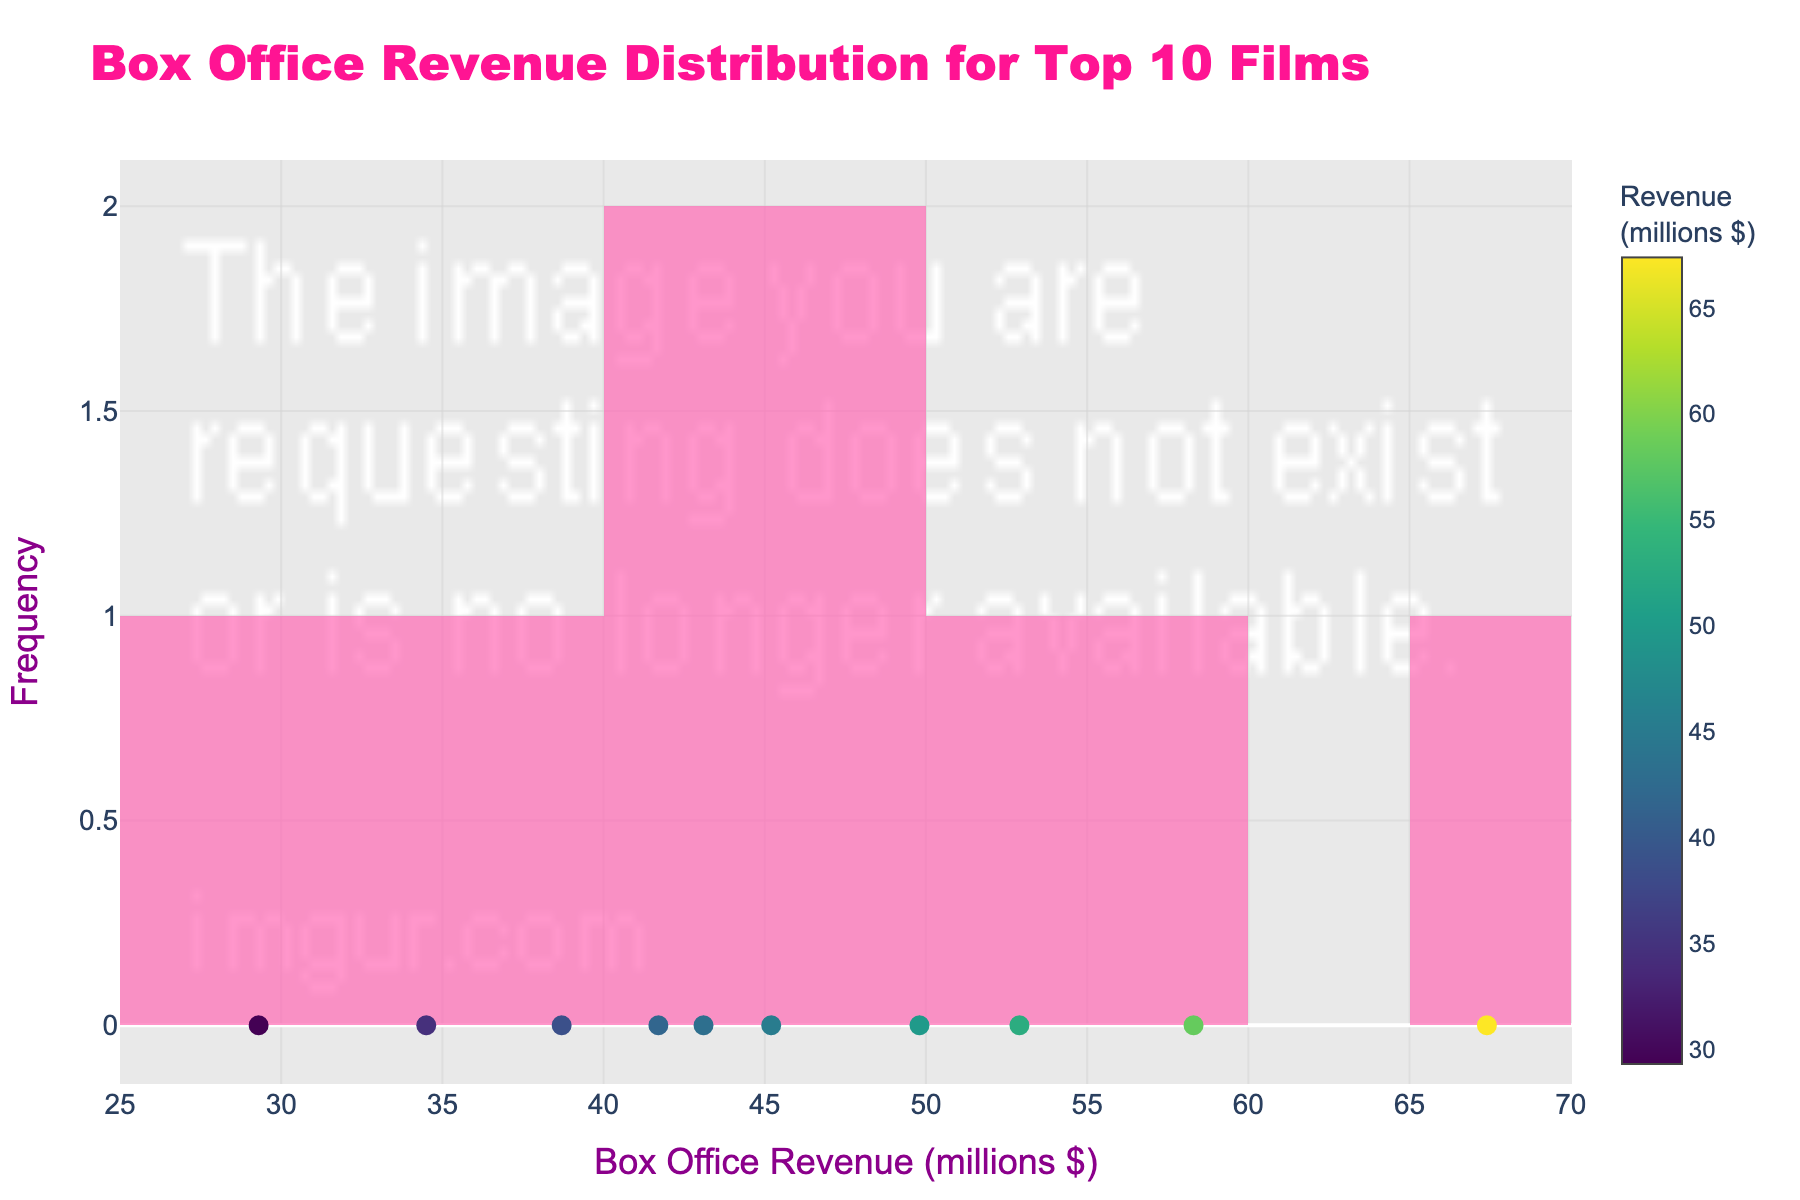What's the title of the plot? The title is prominently displayed at the top of the plot. It provides an overall description of the content of the plot.
Answer: Box Office Revenue Distribution for Top 10 Films What is the x-axis labeled as? The label for the x-axis is shown below the axis and describes what the values along this axis represent.
Answer: Box Office Revenue (millions $) What is the y-axis titled? The title of the y-axis is on the left side of the plot, indicating what the values along this axis represent.
Answer: Frequency How many films are analyzed in this plot? The number of films can be counted from the plot. Markers or data points associated with films are displayed.
Answer: 10 What is the range of the box office revenues for the films? The range can be determined by looking at the minimum and maximum values displayed on the x-axis where the data points (markers) are spread.
Answer: 29.3 to 67.4 million dollars Which film had the highest box office revenue? By observing which marker is farthest to the right on the x-axis and checking the hover information corresponding to it.
Answer: Starstruck What is the median box office revenue for these films? To find the median, the films' revenues need to be ordered from least to greatest and the middle value identified (or the average of the two middle values if the number of films is even).
Answer: 45.2 million dollars Which film is closest to the average box office revenue? First, calculate the average of all the revenues, then see which film's revenue is nearest to this average by inspecting the markers.
Answer: Stardom Rising How many films have box office revenues below 40 million dollars? Count the number of markers that are to the left of the 40 million-dollar mark on the x-axis.
Answer: 3 Which films fall within the range of 50 to 60 million dollars in box office revenue? Identify the films whose markers lie between 50 and 60 million dollars on the x-axis by checking the hover information.
Answer: Elegance Unleashed, Hollywood Heights 